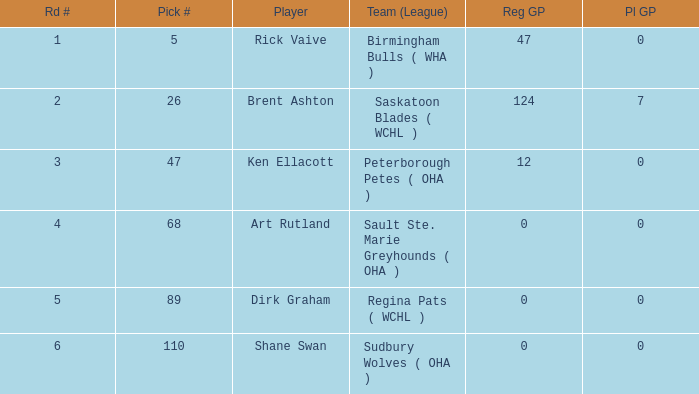How many normal gp for rick vaive in round one? None. 